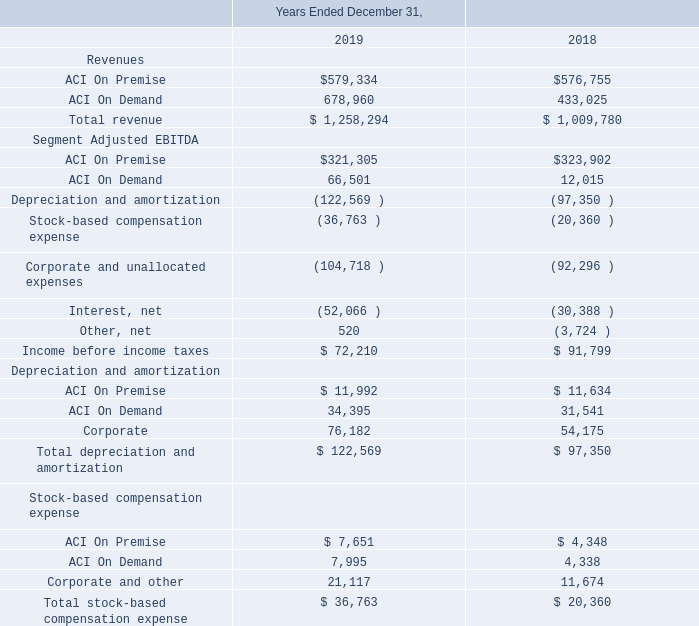The following is selected financial data for our reportable segments (in thousands):
ACI On Premise Segment Adjusted EBITDA decreased $2.6 million for the year ended December 31, 2019, compared to the same period in 2018, primarily due to a $5.2 million increase in cash operating expense, partially offset by a $2.6 million increase in revenue.
ACI On Demand Segment Adjusted EBITDA increased $54.5 million for the year ended December 31, 2019, compared to the same period in 2018, of which $46.4 million was due to the acquisition of Speedpay. Excluding the impact of the acquisition of Speedpay, ACI On Demand Segment Adjusted EBITDA increased $8.1 million, primarily due to a $18.3 million increase in revenue, partially offset by a $10.2 million increase in cash operating expense.
Why did ACI On Premise Segment Adjusted EBITDA decrease between 2018 and 2019? Due to a $5.2 million increase in cash operating expense, partially offset by a $2.6 million increase in revenue. What was the total revenue in 2018?
Answer scale should be: thousand. $ 1,009,780. What was the total stock-based compensation expense in 2019?
Answer scale should be: thousand. $ 36,763. What was the change in Corporate depreciation and amortization between 2018 and 2019?
Answer scale should be: thousand. 76,182-54,175
Answer: 22007. What was the change in ACI on Premise revenues between 2018 and 2019?
Answer scale should be: thousand. $579,334-$576,755
Answer: 2579. What was the percentage change in segment adjusted EBITDA ACI on Premise between 2018 and 2019?
Answer scale should be: percent. ($321,305-$323,902)/$323,902
Answer: -0.8. 